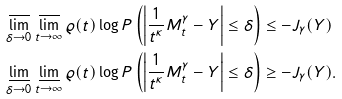Convert formula to latex. <formula><loc_0><loc_0><loc_500><loc_500>& \varlimsup _ { \delta \to 0 } \varlimsup _ { t \to \infty } \varrho ( t ) \log P \left ( \left | \frac { 1 } { t ^ { \kappa } } M ^ { \gamma } _ { t } - Y \right | \leq \delta \right ) \leq - J _ { \gamma } ( Y ) \\ & \varliminf _ { \delta \to 0 } \varliminf _ { t \to \infty } \varrho ( t ) \log P \left ( \left | \frac { 1 } { t ^ { \kappa } } M ^ { \gamma } _ { t } - Y \right | \leq \delta \right ) \geq - J _ { \gamma } ( Y ) .</formula> 